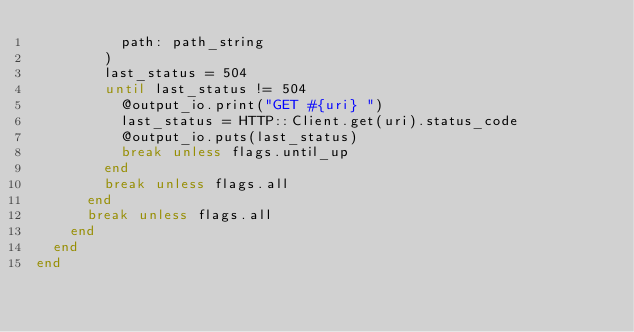<code> <loc_0><loc_0><loc_500><loc_500><_Crystal_>          path: path_string
        )
        last_status = 504
        until last_status != 504
          @output_io.print("GET #{uri} ")
          last_status = HTTP::Client.get(uri).status_code
          @output_io.puts(last_status)
          break unless flags.until_up
        end
        break unless flags.all
      end
      break unless flags.all
    end
  end
end
</code> 